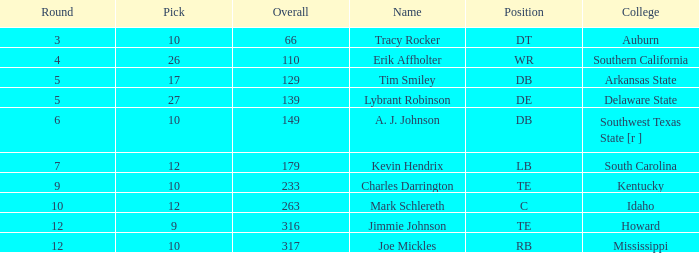What is the average Pick, when Name is "Lybrant Robinson", and when Overall is less than 139? None. 